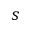Convert formula to latex. <formula><loc_0><loc_0><loc_500><loc_500>s</formula> 